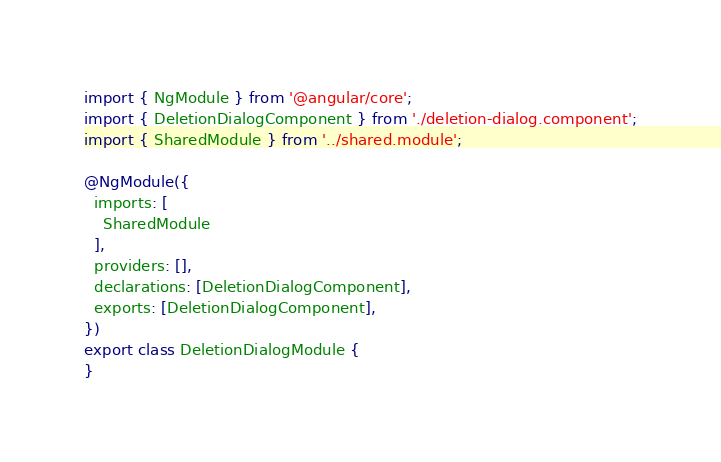Convert code to text. <code><loc_0><loc_0><loc_500><loc_500><_TypeScript_>import { NgModule } from '@angular/core';
import { DeletionDialogComponent } from './deletion-dialog.component';
import { SharedModule } from '../shared.module';

@NgModule({
  imports: [
    SharedModule
  ],
  providers: [],
  declarations: [DeletionDialogComponent],
  exports: [DeletionDialogComponent],
})
export class DeletionDialogModule {
}
</code> 